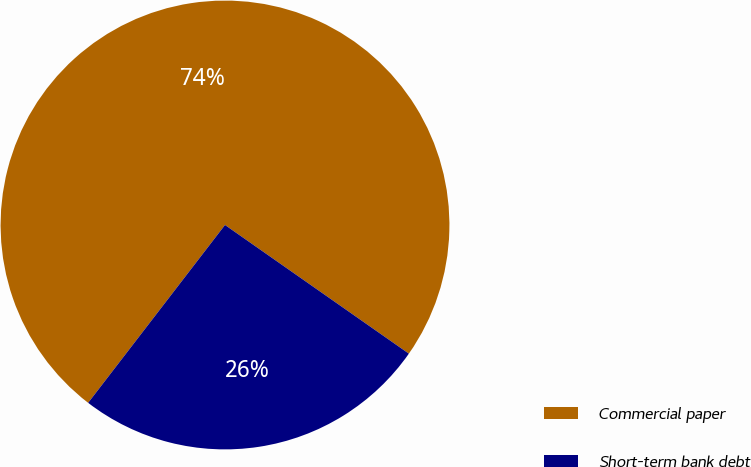Convert chart. <chart><loc_0><loc_0><loc_500><loc_500><pie_chart><fcel>Commercial paper<fcel>Short-term bank debt<nl><fcel>74.28%<fcel>25.72%<nl></chart> 